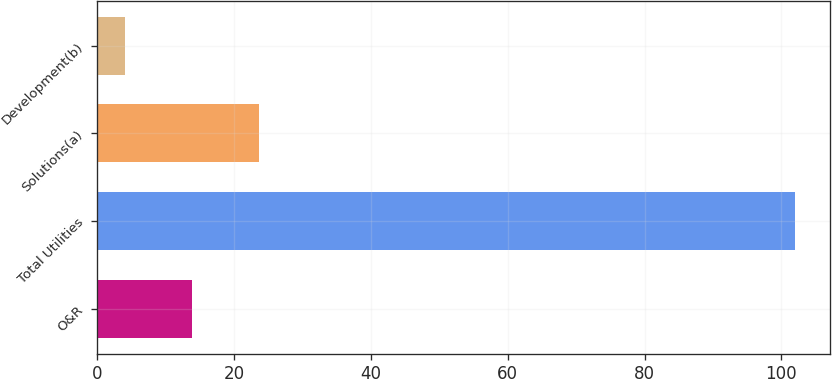<chart> <loc_0><loc_0><loc_500><loc_500><bar_chart><fcel>O&R<fcel>Total Utilities<fcel>Solutions(a)<fcel>Development(b)<nl><fcel>13.8<fcel>102<fcel>23.6<fcel>4<nl></chart> 